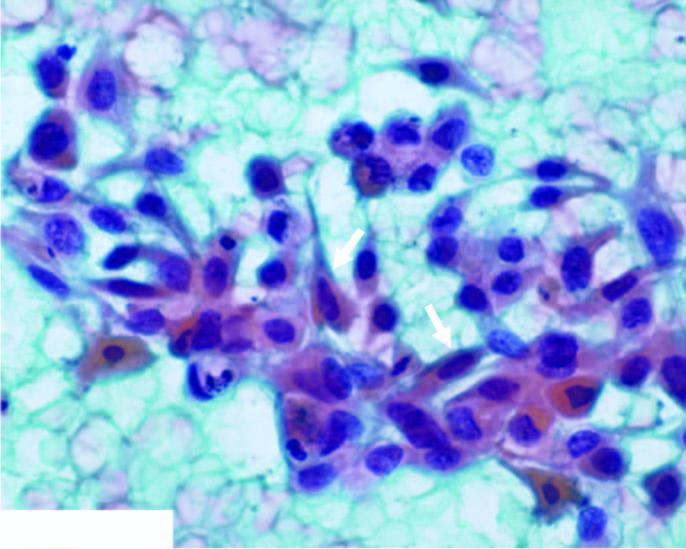what shows abundant haemorrhage and some necrotic debris?
Answer the question using a single word or phrase. The background 